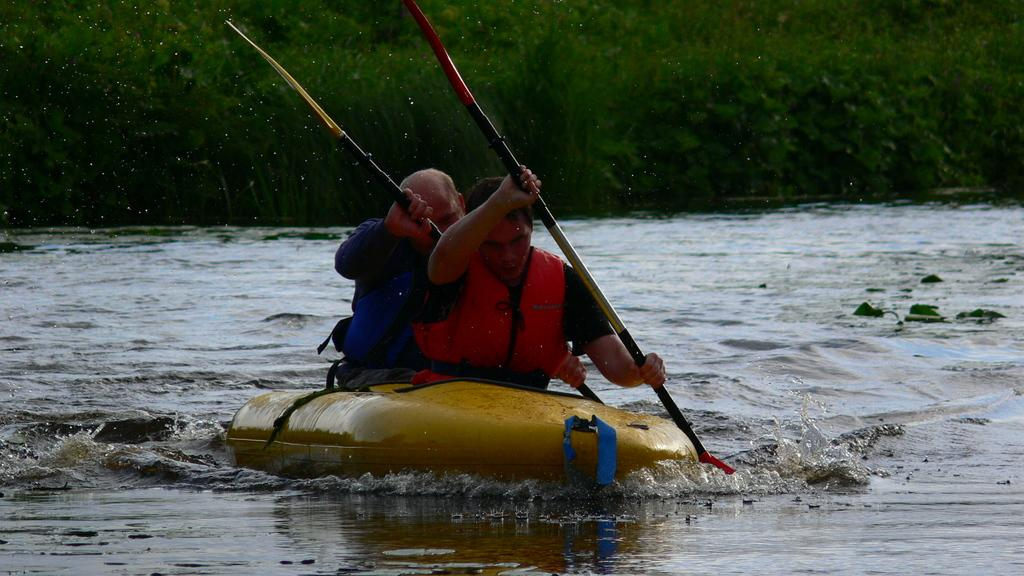What is the primary element present in the image? There is water in the image. What type of boat can be seen in the water? There is a yellow color boat in the image. Who is in the boat? Two men are sitting in the boat. What are the men doing in the boat? The men are riding the boat. What can be seen in the background of the image? There are plants visible in the background of the image. How many wounds can be seen on the plants in the image? There are no wounds visible on the plants in the image, as the provided facts do not mention any wounds or damage to the plants. 